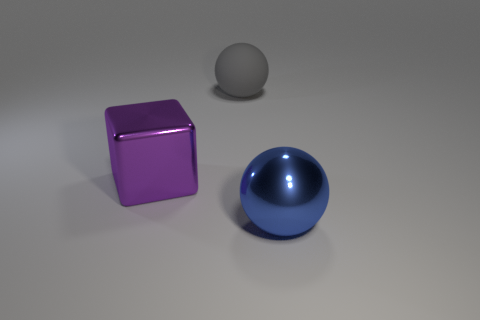How would you describe the atmosphere or mood of this image? The image conveys a minimalist and clean atmosphere, with a neutral background and well-spaced objects. The simple arrangement and the soft lighting give the scene a peaceful and orderly mood, free from clutter and chaos. 